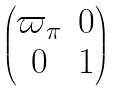<formula> <loc_0><loc_0><loc_500><loc_500>\begin{pmatrix} \varpi _ { \pi } & 0 \\ 0 & 1 \end{pmatrix}</formula> 